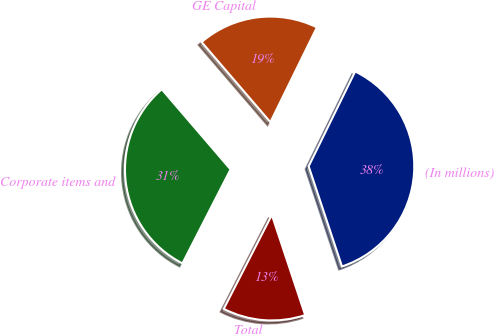Convert chart. <chart><loc_0><loc_0><loc_500><loc_500><pie_chart><fcel>(In millions)<fcel>GE Capital<fcel>Corporate items and<fcel>Total<nl><fcel>37.63%<fcel>18.55%<fcel>31.18%<fcel>12.64%<nl></chart> 